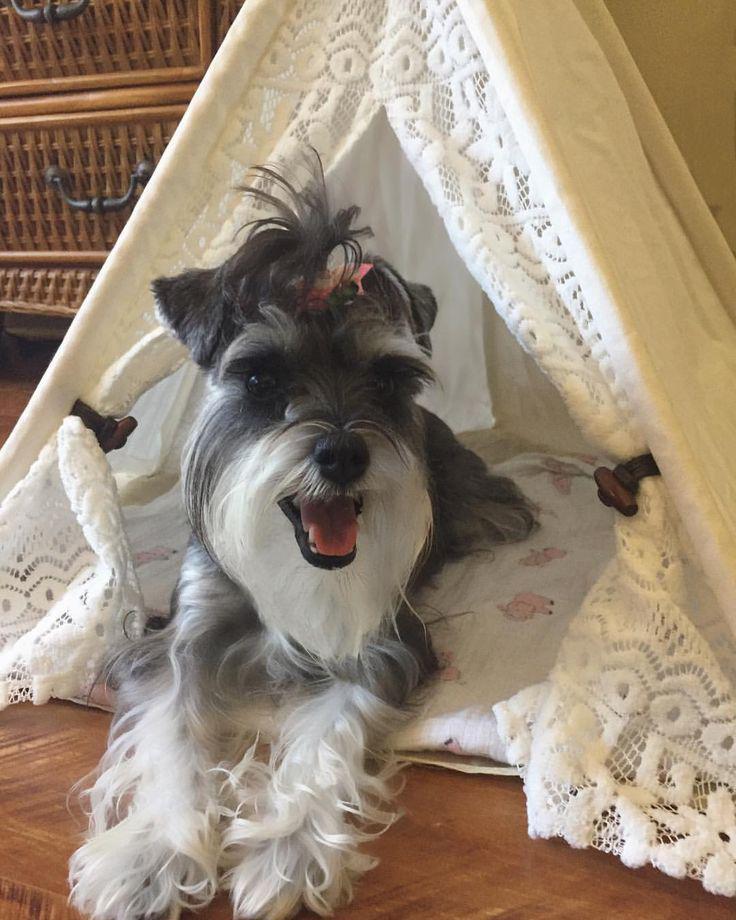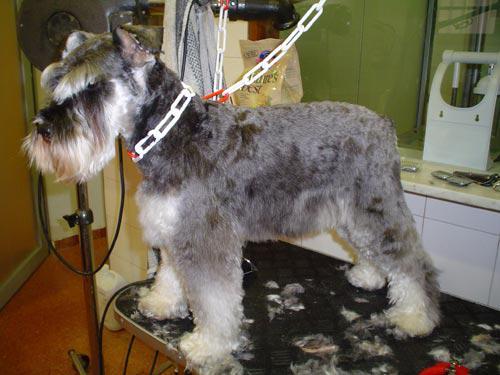The first image is the image on the left, the second image is the image on the right. Considering the images on both sides, is "One image shows a dog standing upright with at least one paw propped on something flat, and the other image includes at least two schnauzers." valid? Answer yes or no. No. 